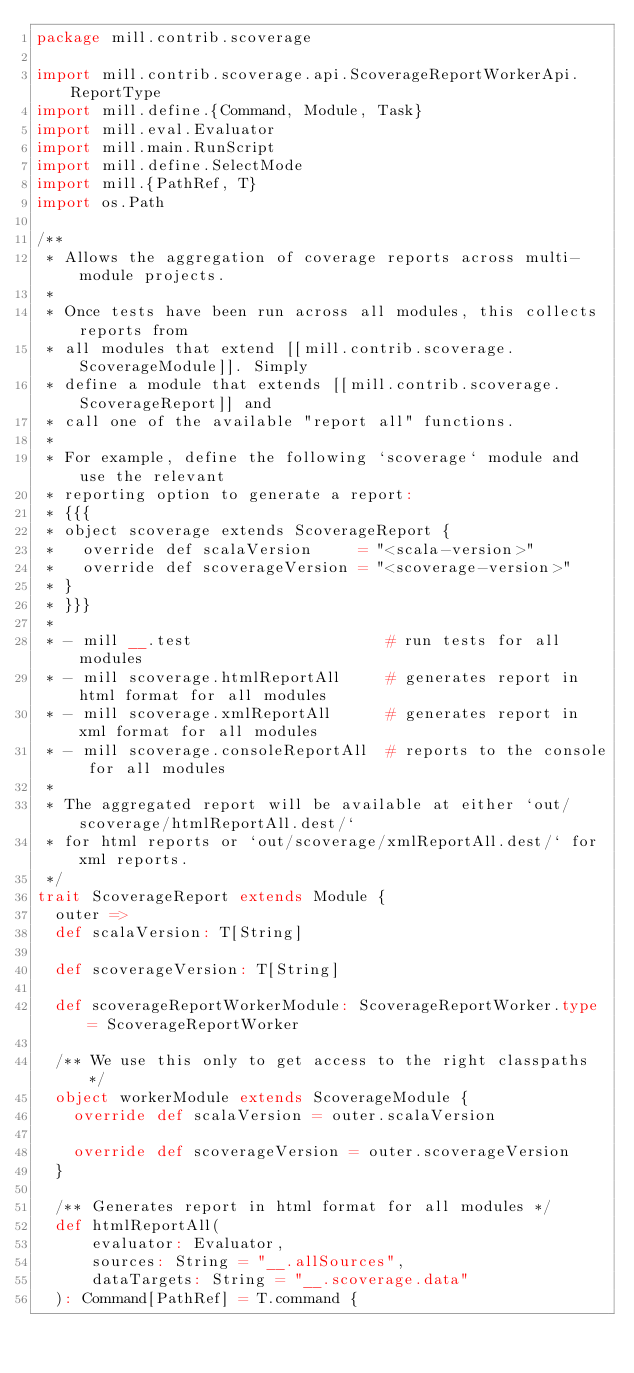Convert code to text. <code><loc_0><loc_0><loc_500><loc_500><_Scala_>package mill.contrib.scoverage

import mill.contrib.scoverage.api.ScoverageReportWorkerApi.ReportType
import mill.define.{Command, Module, Task}
import mill.eval.Evaluator
import mill.main.RunScript
import mill.define.SelectMode
import mill.{PathRef, T}
import os.Path

/**
 * Allows the aggregation of coverage reports across multi-module projects.
 *
 * Once tests have been run across all modules, this collects reports from
 * all modules that extend [[mill.contrib.scoverage.ScoverageModule]]. Simply
 * define a module that extends [[mill.contrib.scoverage.ScoverageReport]] and
 * call one of the available "report all" functions.
 *
 * For example, define the following `scoverage` module and use the relevant
 * reporting option to generate a report:
 * {{{
 * object scoverage extends ScoverageReport {
 *   override def scalaVersion     = "<scala-version>"
 *   override def scoverageVersion = "<scoverage-version>"
 * }
 * }}}
 *
 * - mill __.test                     # run tests for all modules
 * - mill scoverage.htmlReportAll     # generates report in html format for all modules
 * - mill scoverage.xmlReportAll      # generates report in xml format for all modules
 * - mill scoverage.consoleReportAll  # reports to the console for all modules
 *
 * The aggregated report will be available at either `out/scoverage/htmlReportAll.dest/`
 * for html reports or `out/scoverage/xmlReportAll.dest/` for xml reports.
 */
trait ScoverageReport extends Module {
  outer =>
  def scalaVersion: T[String]

  def scoverageVersion: T[String]

  def scoverageReportWorkerModule: ScoverageReportWorker.type = ScoverageReportWorker

  /** We use this only to get access to the right classpaths */
  object workerModule extends ScoverageModule {
    override def scalaVersion = outer.scalaVersion

    override def scoverageVersion = outer.scoverageVersion
  }

  /** Generates report in html format for all modules */
  def htmlReportAll(
      evaluator: Evaluator,
      sources: String = "__.allSources",
      dataTargets: String = "__.scoverage.data"
  ): Command[PathRef] = T.command {</code> 